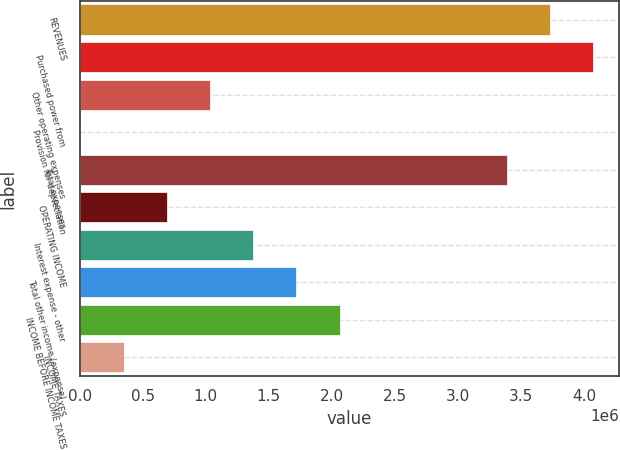<chart> <loc_0><loc_0><loc_500><loc_500><bar_chart><fcel>REVENUES<fcel>Purchased power from<fcel>Other operating expenses<fcel>Provision for depreciation<fcel>Total expenses<fcel>OPERATING INCOME<fcel>Interest expense - other<fcel>Total other income (expense)<fcel>INCOME BEFORE INCOME TAXES<fcel>INCOME TAXES<nl><fcel>3.731e+06<fcel>4.07364e+06<fcel>1.03329e+06<fcel>5379<fcel>3.38837e+06<fcel>690652<fcel>1.37592e+06<fcel>1.71856e+06<fcel>2.0612e+06<fcel>348016<nl></chart> 